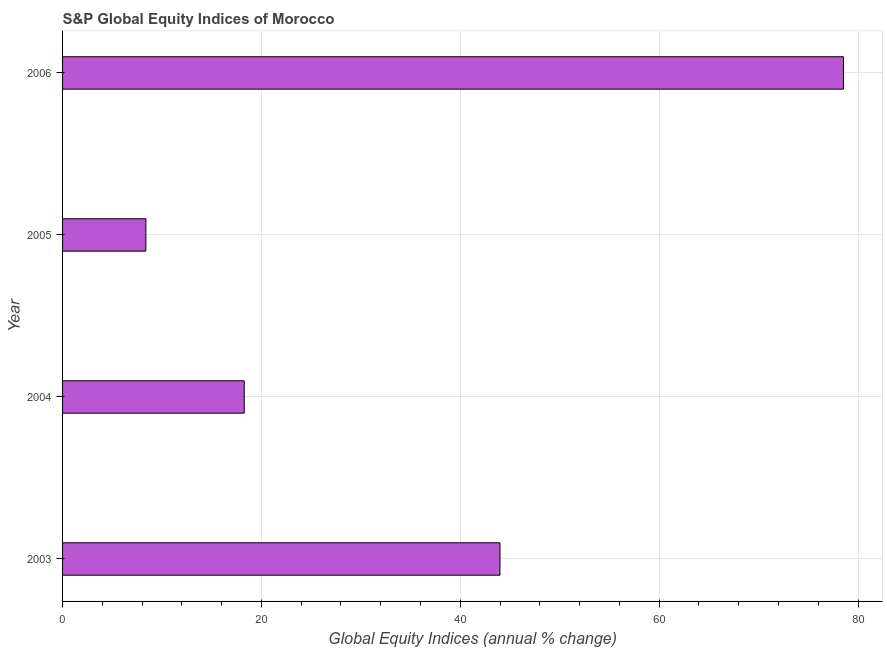Does the graph contain any zero values?
Keep it short and to the point. No. Does the graph contain grids?
Keep it short and to the point. Yes. What is the title of the graph?
Give a very brief answer. S&P Global Equity Indices of Morocco. What is the label or title of the X-axis?
Make the answer very short. Global Equity Indices (annual % change). What is the label or title of the Y-axis?
Your answer should be very brief. Year. What is the s&p global equity indices in 2006?
Offer a terse response. 78.53. Across all years, what is the maximum s&p global equity indices?
Ensure brevity in your answer.  78.53. Across all years, what is the minimum s&p global equity indices?
Your answer should be very brief. 8.38. In which year was the s&p global equity indices maximum?
Offer a terse response. 2006. What is the sum of the s&p global equity indices?
Your answer should be very brief. 149.17. What is the difference between the s&p global equity indices in 2003 and 2006?
Offer a terse response. -34.55. What is the average s&p global equity indices per year?
Make the answer very short. 37.29. What is the median s&p global equity indices?
Ensure brevity in your answer.  31.13. In how many years, is the s&p global equity indices greater than 52 %?
Keep it short and to the point. 1. Do a majority of the years between 2004 and 2005 (inclusive) have s&p global equity indices greater than 60 %?
Provide a succinct answer. No. What is the ratio of the s&p global equity indices in 2003 to that in 2006?
Provide a short and direct response. 0.56. Is the s&p global equity indices in 2003 less than that in 2004?
Provide a short and direct response. No. Is the difference between the s&p global equity indices in 2004 and 2006 greater than the difference between any two years?
Provide a succinct answer. No. What is the difference between the highest and the second highest s&p global equity indices?
Offer a very short reply. 34.55. What is the difference between the highest and the lowest s&p global equity indices?
Keep it short and to the point. 70.16. Are all the bars in the graph horizontal?
Provide a succinct answer. Yes. How many years are there in the graph?
Make the answer very short. 4. What is the Global Equity Indices (annual % change) in 2003?
Keep it short and to the point. 43.99. What is the Global Equity Indices (annual % change) in 2004?
Provide a succinct answer. 18.27. What is the Global Equity Indices (annual % change) in 2005?
Offer a terse response. 8.38. What is the Global Equity Indices (annual % change) of 2006?
Give a very brief answer. 78.53. What is the difference between the Global Equity Indices (annual % change) in 2003 and 2004?
Offer a terse response. 25.72. What is the difference between the Global Equity Indices (annual % change) in 2003 and 2005?
Offer a very short reply. 35.61. What is the difference between the Global Equity Indices (annual % change) in 2003 and 2006?
Your answer should be compact. -34.54. What is the difference between the Global Equity Indices (annual % change) in 2004 and 2005?
Ensure brevity in your answer.  9.89. What is the difference between the Global Equity Indices (annual % change) in 2004 and 2006?
Keep it short and to the point. -60.26. What is the difference between the Global Equity Indices (annual % change) in 2005 and 2006?
Give a very brief answer. -70.16. What is the ratio of the Global Equity Indices (annual % change) in 2003 to that in 2004?
Make the answer very short. 2.41. What is the ratio of the Global Equity Indices (annual % change) in 2003 to that in 2005?
Your response must be concise. 5.25. What is the ratio of the Global Equity Indices (annual % change) in 2003 to that in 2006?
Provide a short and direct response. 0.56. What is the ratio of the Global Equity Indices (annual % change) in 2004 to that in 2005?
Your response must be concise. 2.18. What is the ratio of the Global Equity Indices (annual % change) in 2004 to that in 2006?
Your response must be concise. 0.23. What is the ratio of the Global Equity Indices (annual % change) in 2005 to that in 2006?
Offer a very short reply. 0.11. 